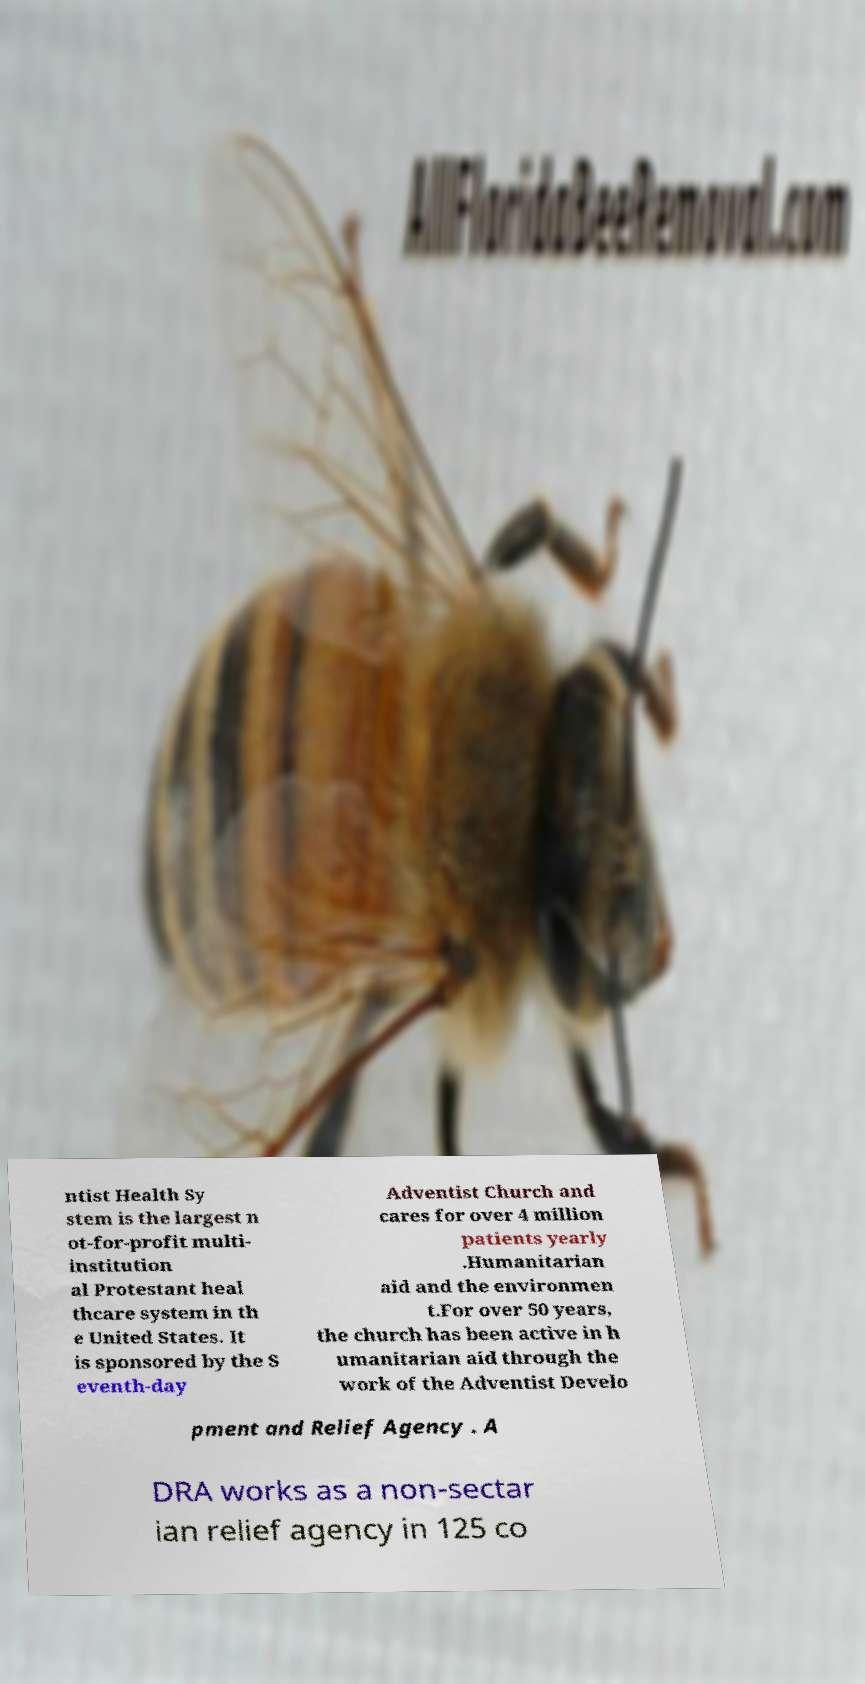For documentation purposes, I need the text within this image transcribed. Could you provide that? ntist Health Sy stem is the largest n ot-for-profit multi- institution al Protestant heal thcare system in th e United States. It is sponsored by the S eventh-day Adventist Church and cares for over 4 million patients yearly .Humanitarian aid and the environmen t.For over 50 years, the church has been active in h umanitarian aid through the work of the Adventist Develo pment and Relief Agency . A DRA works as a non-sectar ian relief agency in 125 co 